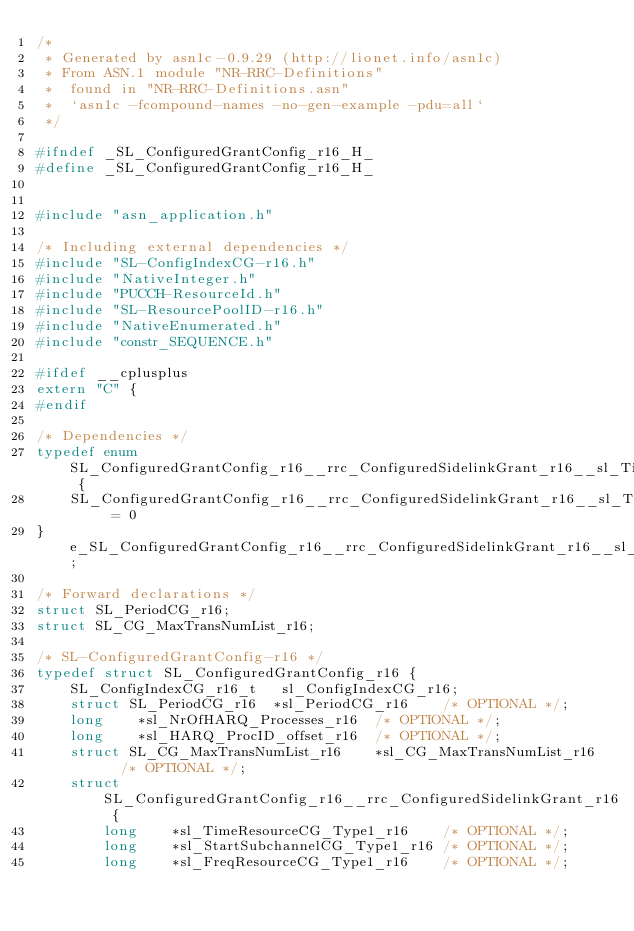Convert code to text. <code><loc_0><loc_0><loc_500><loc_500><_C_>/*
 * Generated by asn1c-0.9.29 (http://lionet.info/asn1c)
 * From ASN.1 module "NR-RRC-Definitions"
 * 	found in "NR-RRC-Definitions.asn"
 * 	`asn1c -fcompound-names -no-gen-example -pdu=all`
 */

#ifndef	_SL_ConfiguredGrantConfig_r16_H_
#define	_SL_ConfiguredGrantConfig_r16_H_


#include "asn_application.h"

/* Including external dependencies */
#include "SL-ConfigIndexCG-r16.h"
#include "NativeInteger.h"
#include "PUCCH-ResourceId.h"
#include "SL-ResourcePoolID-r16.h"
#include "NativeEnumerated.h"
#include "constr_SEQUENCE.h"

#ifdef __cplusplus
extern "C" {
#endif

/* Dependencies */
typedef enum SL_ConfiguredGrantConfig_r16__rrc_ConfiguredSidelinkGrant_r16__sl_TimeReferenceSFN_Type1_r16 {
	SL_ConfiguredGrantConfig_r16__rrc_ConfiguredSidelinkGrant_r16__sl_TimeReferenceSFN_Type1_r16_sfn512	= 0
} e_SL_ConfiguredGrantConfig_r16__rrc_ConfiguredSidelinkGrant_r16__sl_TimeReferenceSFN_Type1_r16;

/* Forward declarations */
struct SL_PeriodCG_r16;
struct SL_CG_MaxTransNumList_r16;

/* SL-ConfiguredGrantConfig-r16 */
typedef struct SL_ConfiguredGrantConfig_r16 {
	SL_ConfigIndexCG_r16_t	 sl_ConfigIndexCG_r16;
	struct SL_PeriodCG_r16	*sl_PeriodCG_r16	/* OPTIONAL */;
	long	*sl_NrOfHARQ_Processes_r16	/* OPTIONAL */;
	long	*sl_HARQ_ProcID_offset_r16	/* OPTIONAL */;
	struct SL_CG_MaxTransNumList_r16	*sl_CG_MaxTransNumList_r16	/* OPTIONAL */;
	struct SL_ConfiguredGrantConfig_r16__rrc_ConfiguredSidelinkGrant_r16 {
		long	*sl_TimeResourceCG_Type1_r16	/* OPTIONAL */;
		long	*sl_StartSubchannelCG_Type1_r16	/* OPTIONAL */;
		long	*sl_FreqResourceCG_Type1_r16	/* OPTIONAL */;</code> 